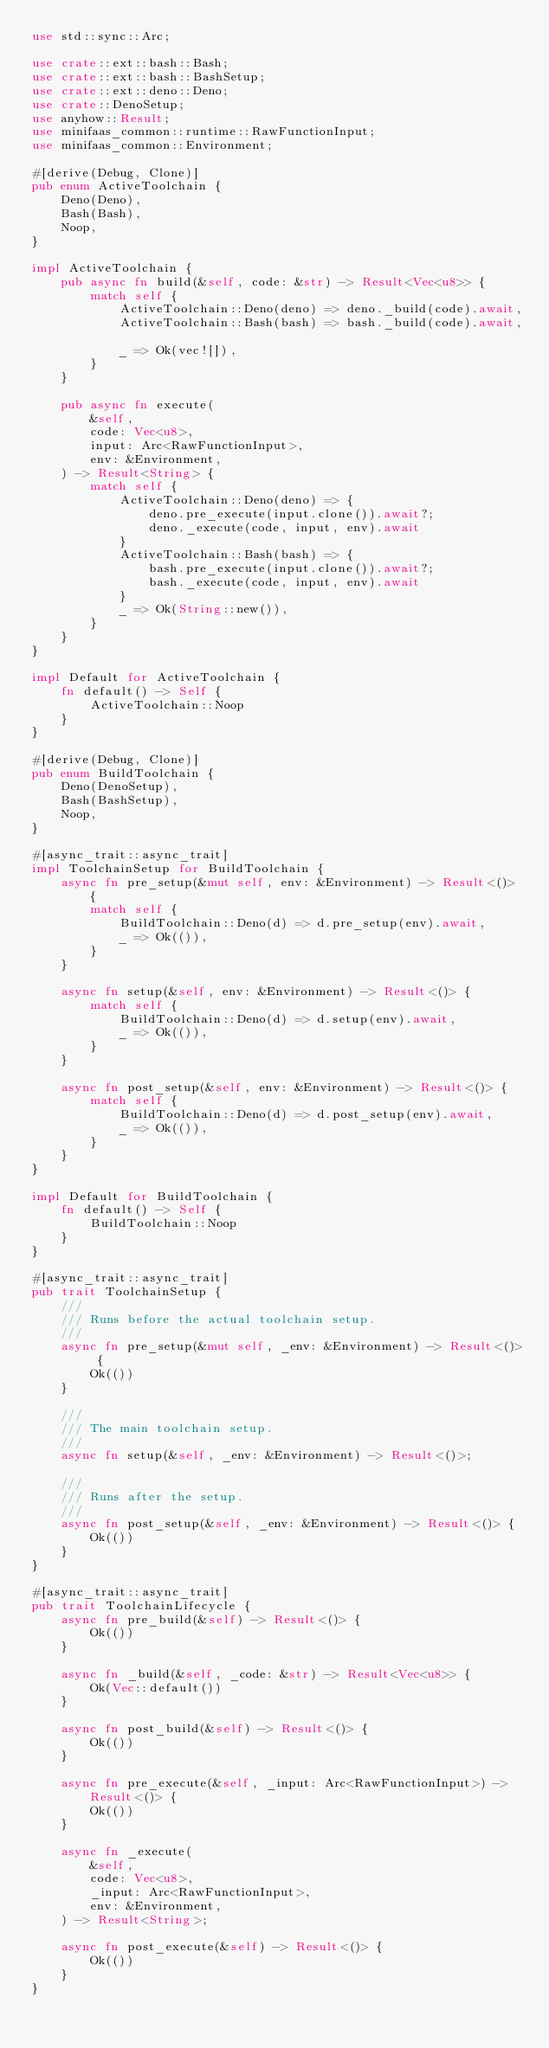<code> <loc_0><loc_0><loc_500><loc_500><_Rust_>use std::sync::Arc;

use crate::ext::bash::Bash;
use crate::ext::bash::BashSetup;
use crate::ext::deno::Deno;
use crate::DenoSetup;
use anyhow::Result;
use minifaas_common::runtime::RawFunctionInput;
use minifaas_common::Environment;

#[derive(Debug, Clone)]
pub enum ActiveToolchain {
    Deno(Deno),
    Bash(Bash),
    Noop,
}

impl ActiveToolchain {
    pub async fn build(&self, code: &str) -> Result<Vec<u8>> {
        match self {
            ActiveToolchain::Deno(deno) => deno._build(code).await,
            ActiveToolchain::Bash(bash) => bash._build(code).await,

            _ => Ok(vec![]),
        }
    }

    pub async fn execute(
        &self,
        code: Vec<u8>,
        input: Arc<RawFunctionInput>,
        env: &Environment,
    ) -> Result<String> {
        match self {
            ActiveToolchain::Deno(deno) => {
                deno.pre_execute(input.clone()).await?;
                deno._execute(code, input, env).await
            }
            ActiveToolchain::Bash(bash) => {
                bash.pre_execute(input.clone()).await?;
                bash._execute(code, input, env).await
            }
            _ => Ok(String::new()),
        }
    }
}

impl Default for ActiveToolchain {
    fn default() -> Self {
        ActiveToolchain::Noop
    }
}

#[derive(Debug, Clone)]
pub enum BuildToolchain {
    Deno(DenoSetup),
    Bash(BashSetup),
    Noop,
}

#[async_trait::async_trait]
impl ToolchainSetup for BuildToolchain {
    async fn pre_setup(&mut self, env: &Environment) -> Result<()> {
        match self {
            BuildToolchain::Deno(d) => d.pre_setup(env).await,
            _ => Ok(()),
        }
    }

    async fn setup(&self, env: &Environment) -> Result<()> {
        match self {
            BuildToolchain::Deno(d) => d.setup(env).await,
            _ => Ok(()),
        }
    }

    async fn post_setup(&self, env: &Environment) -> Result<()> {
        match self {
            BuildToolchain::Deno(d) => d.post_setup(env).await,
            _ => Ok(()),
        }
    }
}

impl Default for BuildToolchain {
    fn default() -> Self {
        BuildToolchain::Noop
    }
}

#[async_trait::async_trait]
pub trait ToolchainSetup {
    ///
    /// Runs before the actual toolchain setup.
    ///
    async fn pre_setup(&mut self, _env: &Environment) -> Result<()> {
        Ok(())
    }

    ///
    /// The main toolchain setup.
    ///
    async fn setup(&self, _env: &Environment) -> Result<()>;

    ///
    /// Runs after the setup.
    ///
    async fn post_setup(&self, _env: &Environment) -> Result<()> {
        Ok(())
    }
}

#[async_trait::async_trait]
pub trait ToolchainLifecycle {
    async fn pre_build(&self) -> Result<()> {
        Ok(())
    }

    async fn _build(&self, _code: &str) -> Result<Vec<u8>> {
        Ok(Vec::default())
    }

    async fn post_build(&self) -> Result<()> {
        Ok(())
    }

    async fn pre_execute(&self, _input: Arc<RawFunctionInput>) -> Result<()> {
        Ok(())
    }

    async fn _execute(
        &self,
        code: Vec<u8>,
        _input: Arc<RawFunctionInput>,
        env: &Environment,
    ) -> Result<String>;

    async fn post_execute(&self) -> Result<()> {
        Ok(())
    }
}
</code> 